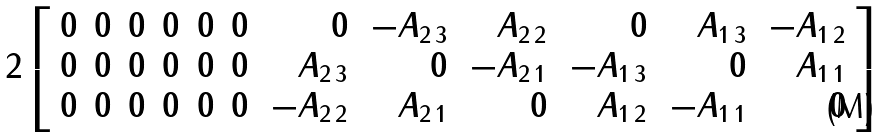<formula> <loc_0><loc_0><loc_500><loc_500>2 \left [ \begin{array} { r r r r r r r r r r r r } 0 & 0 & 0 & 0 & 0 & 0 & \, 0 & \, - A _ { 2 \, 3 } & \, A _ { 2 \, 2 } & \, 0 & \, A _ { 1 \, 3 } & \, - A _ { 1 \, 2 } \\ 0 & 0 & 0 & 0 & 0 & 0 & \, A _ { 2 \, 3 } & \, 0 & \, - A _ { 2 \, 1 } & \, - A _ { 1 \, 3 } & \, 0 & A _ { 1 \, 1 } \\ 0 & 0 & 0 & 0 & 0 & 0 & \, - A _ { 2 \, 2 } & \, A _ { 2 \, 1 } & \, 0 & \, A _ { 1 \, 2 } & \, - A _ { 1 \, 1 } & \, 0 \end{array} \right ]</formula> 